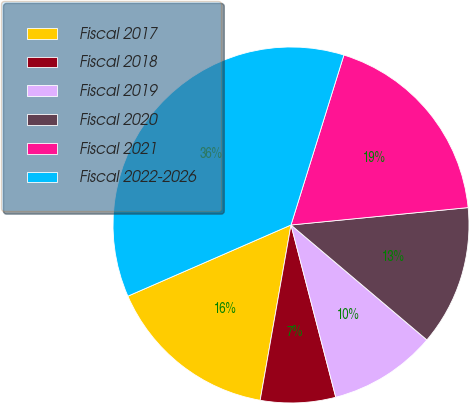Convert chart. <chart><loc_0><loc_0><loc_500><loc_500><pie_chart><fcel>Fiscal 2017<fcel>Fiscal 2018<fcel>Fiscal 2019<fcel>Fiscal 2020<fcel>Fiscal 2021<fcel>Fiscal 2022-2026<nl><fcel>15.68%<fcel>6.82%<fcel>9.78%<fcel>12.73%<fcel>18.64%<fcel>36.35%<nl></chart> 